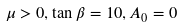Convert formula to latex. <formula><loc_0><loc_0><loc_500><loc_500>\mu > 0 , \tan \beta = 1 0 , A _ { 0 } = 0</formula> 